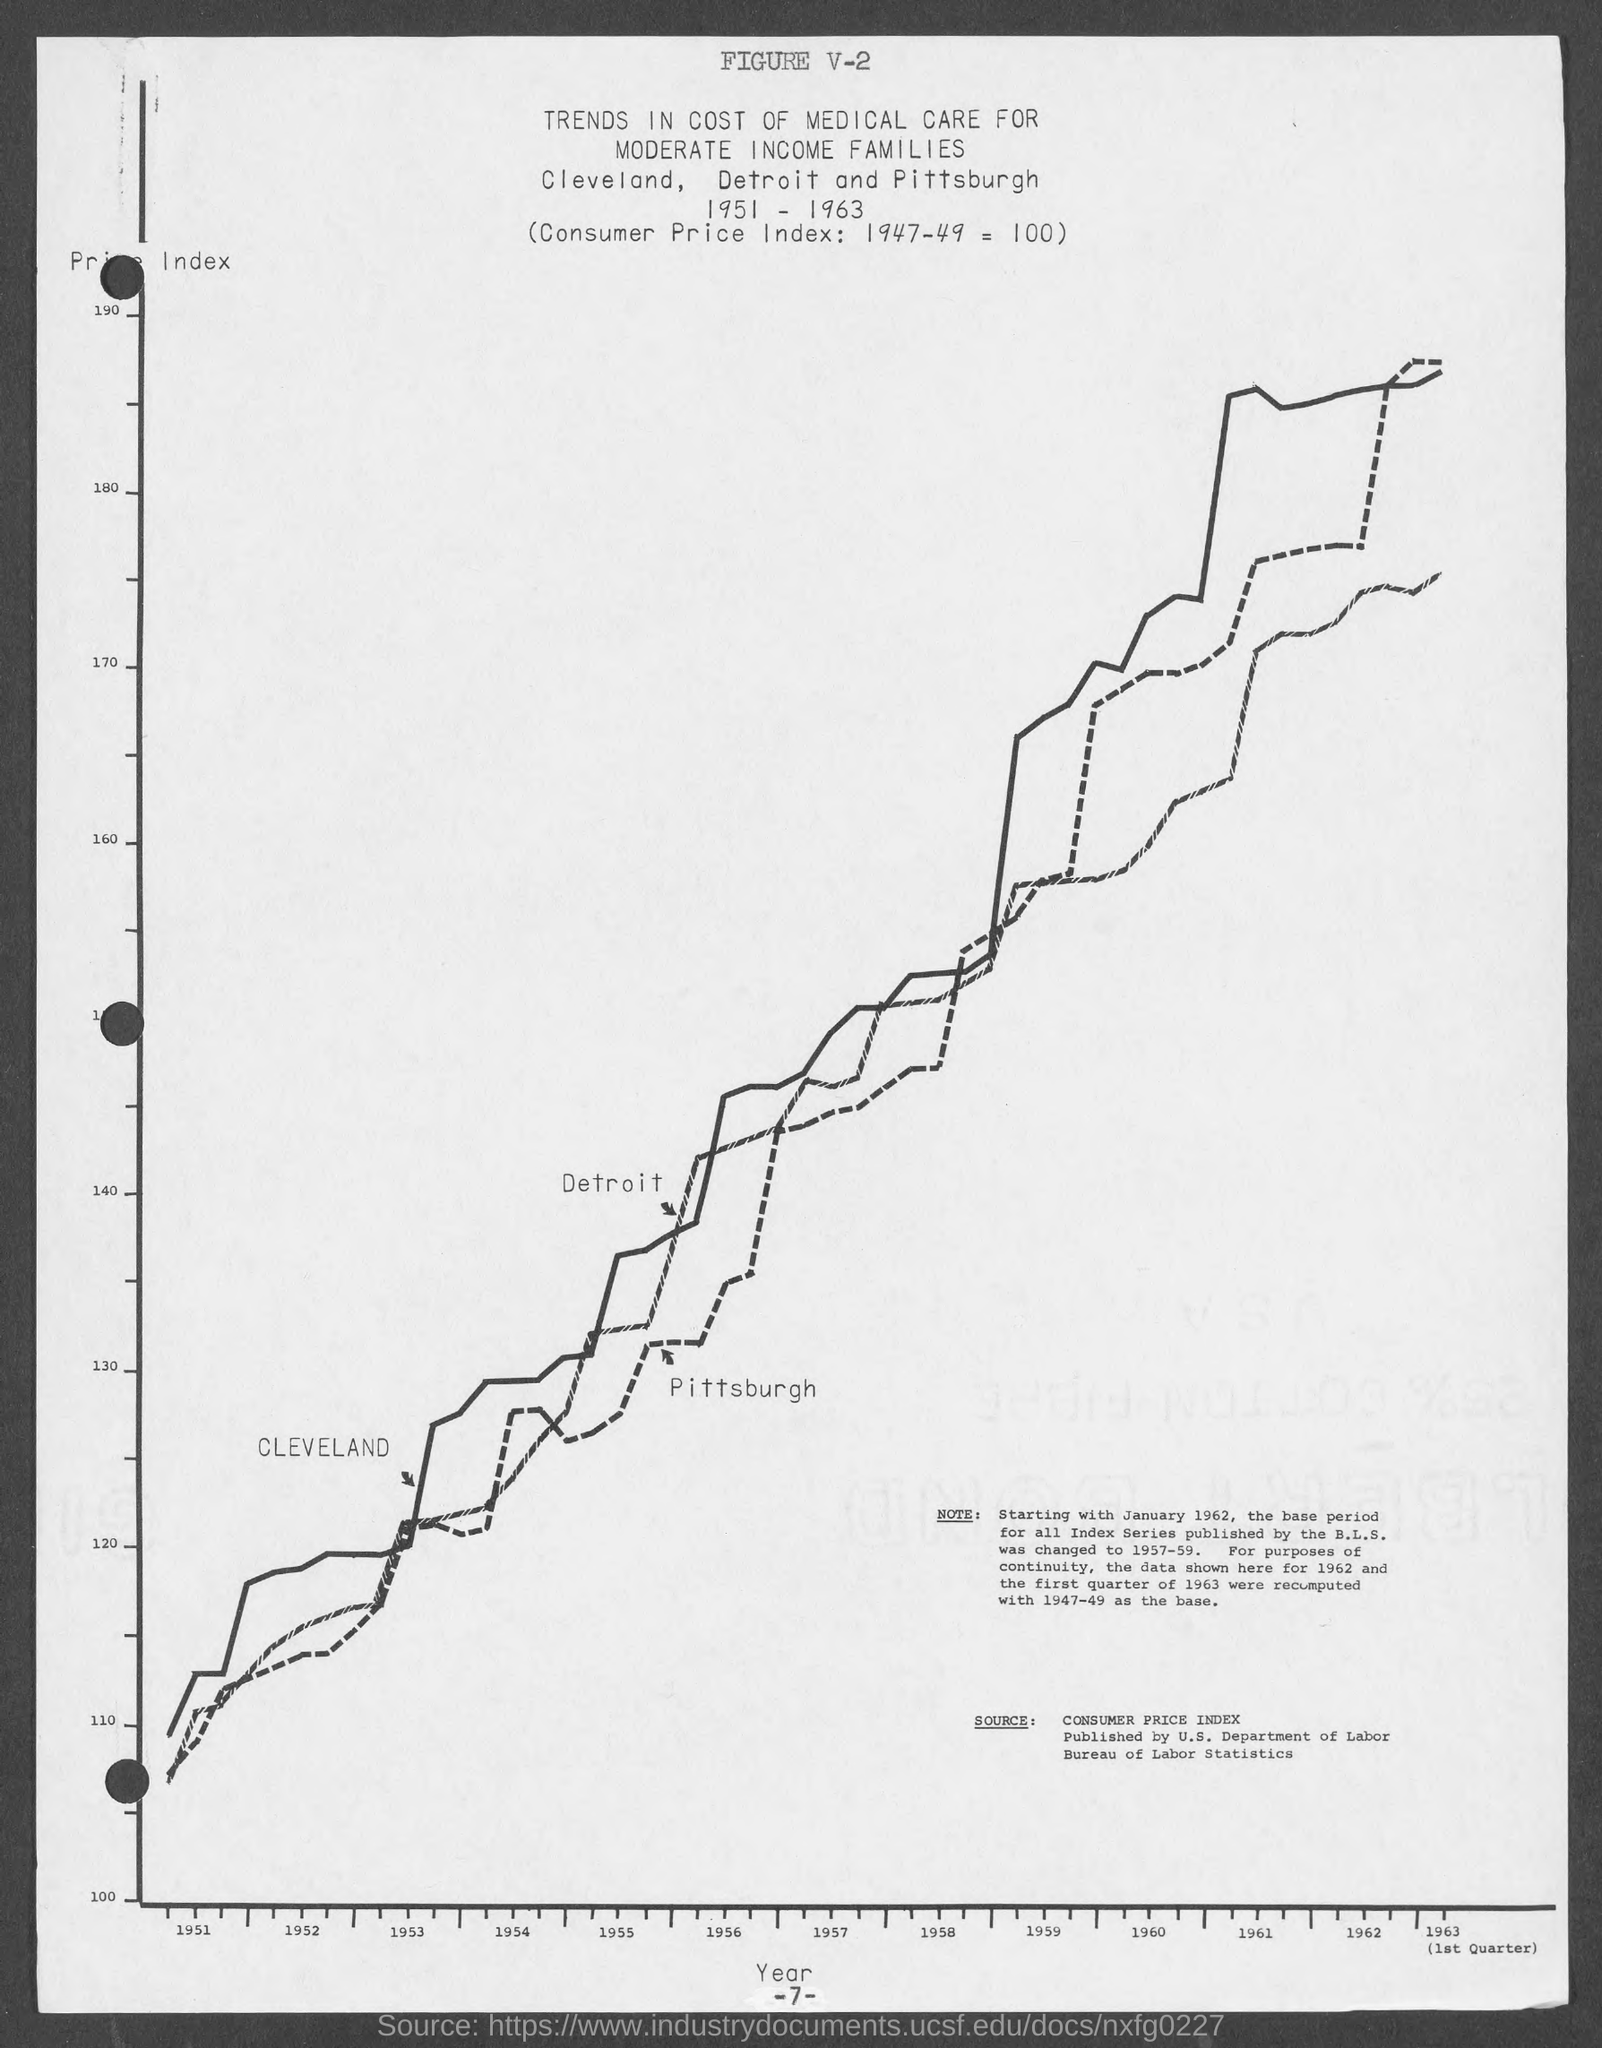What is the figure no.?
Offer a very short reply. V-2. What is the number at bottom of the page ?
Provide a succinct answer. -7-. 